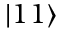Convert formula to latex. <formula><loc_0><loc_0><loc_500><loc_500>| 1 1 \rangle</formula> 